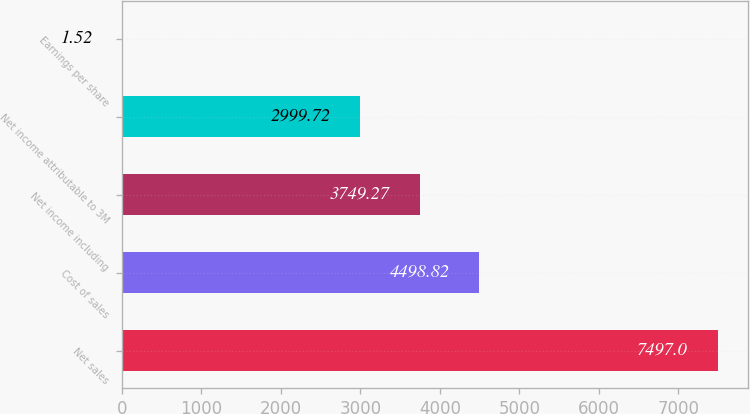Convert chart to OTSL. <chart><loc_0><loc_0><loc_500><loc_500><bar_chart><fcel>Net sales<fcel>Cost of sales<fcel>Net income including<fcel>Net income attributable to 3M<fcel>Earnings per share<nl><fcel>7497<fcel>4498.82<fcel>3749.27<fcel>2999.72<fcel>1.52<nl></chart> 